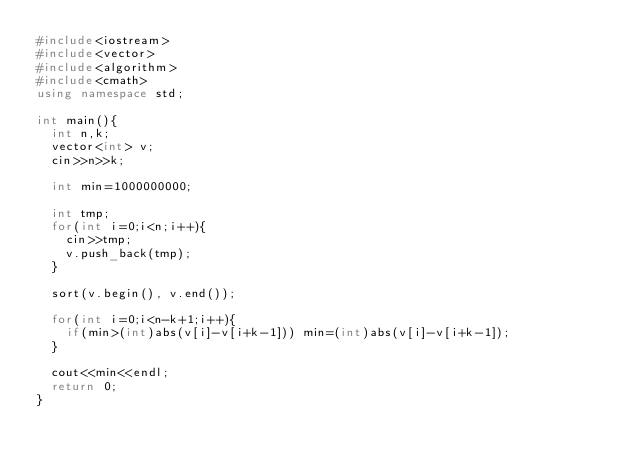Convert code to text. <code><loc_0><loc_0><loc_500><loc_500><_C++_>#include<iostream>
#include<vector>
#include<algorithm>
#include<cmath>
using namespace std;

int main(){
  int n,k;
  vector<int> v;
  cin>>n>>k;

  int min=1000000000;

  int tmp;
  for(int i=0;i<n;i++){
    cin>>tmp;
    v.push_back(tmp);
  }

  sort(v.begin(), v.end());

  for(int i=0;i<n-k+1;i++){
    if(min>(int)abs(v[i]-v[i+k-1])) min=(int)abs(v[i]-v[i+k-1]);
  }

  cout<<min<<endl;
  return 0;
}
</code> 